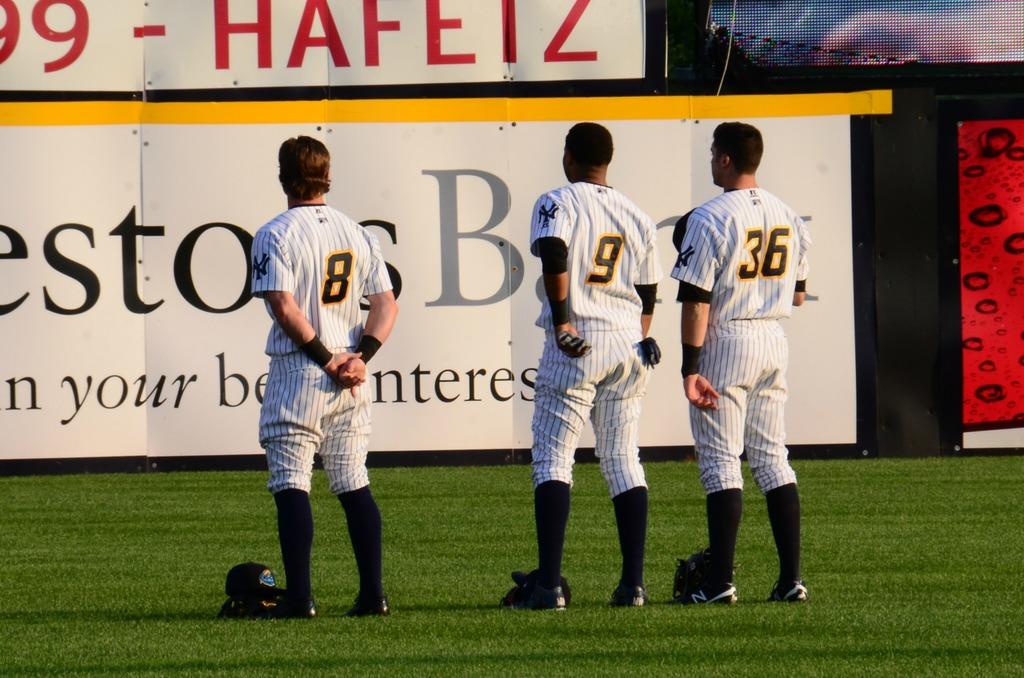What is the player number on the right?
Your response must be concise. 36. 